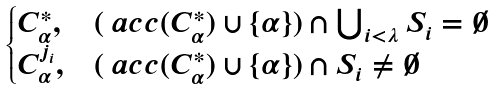Convert formula to latex. <formula><loc_0><loc_0><loc_500><loc_500>\begin{cases} C _ { \alpha } ^ { * } , & ( \ a c c ( C _ { \alpha } ^ { * } ) \cup \{ \alpha \} ) \cap \bigcup _ { i < \lambda } S _ { i } = \emptyset \\ C _ { \alpha } ^ { j _ { i } } , & ( \ a c c ( C _ { \alpha } ^ { * } ) \cup \{ \alpha \} ) \cap S _ { i } \not = \emptyset \end{cases}</formula> 